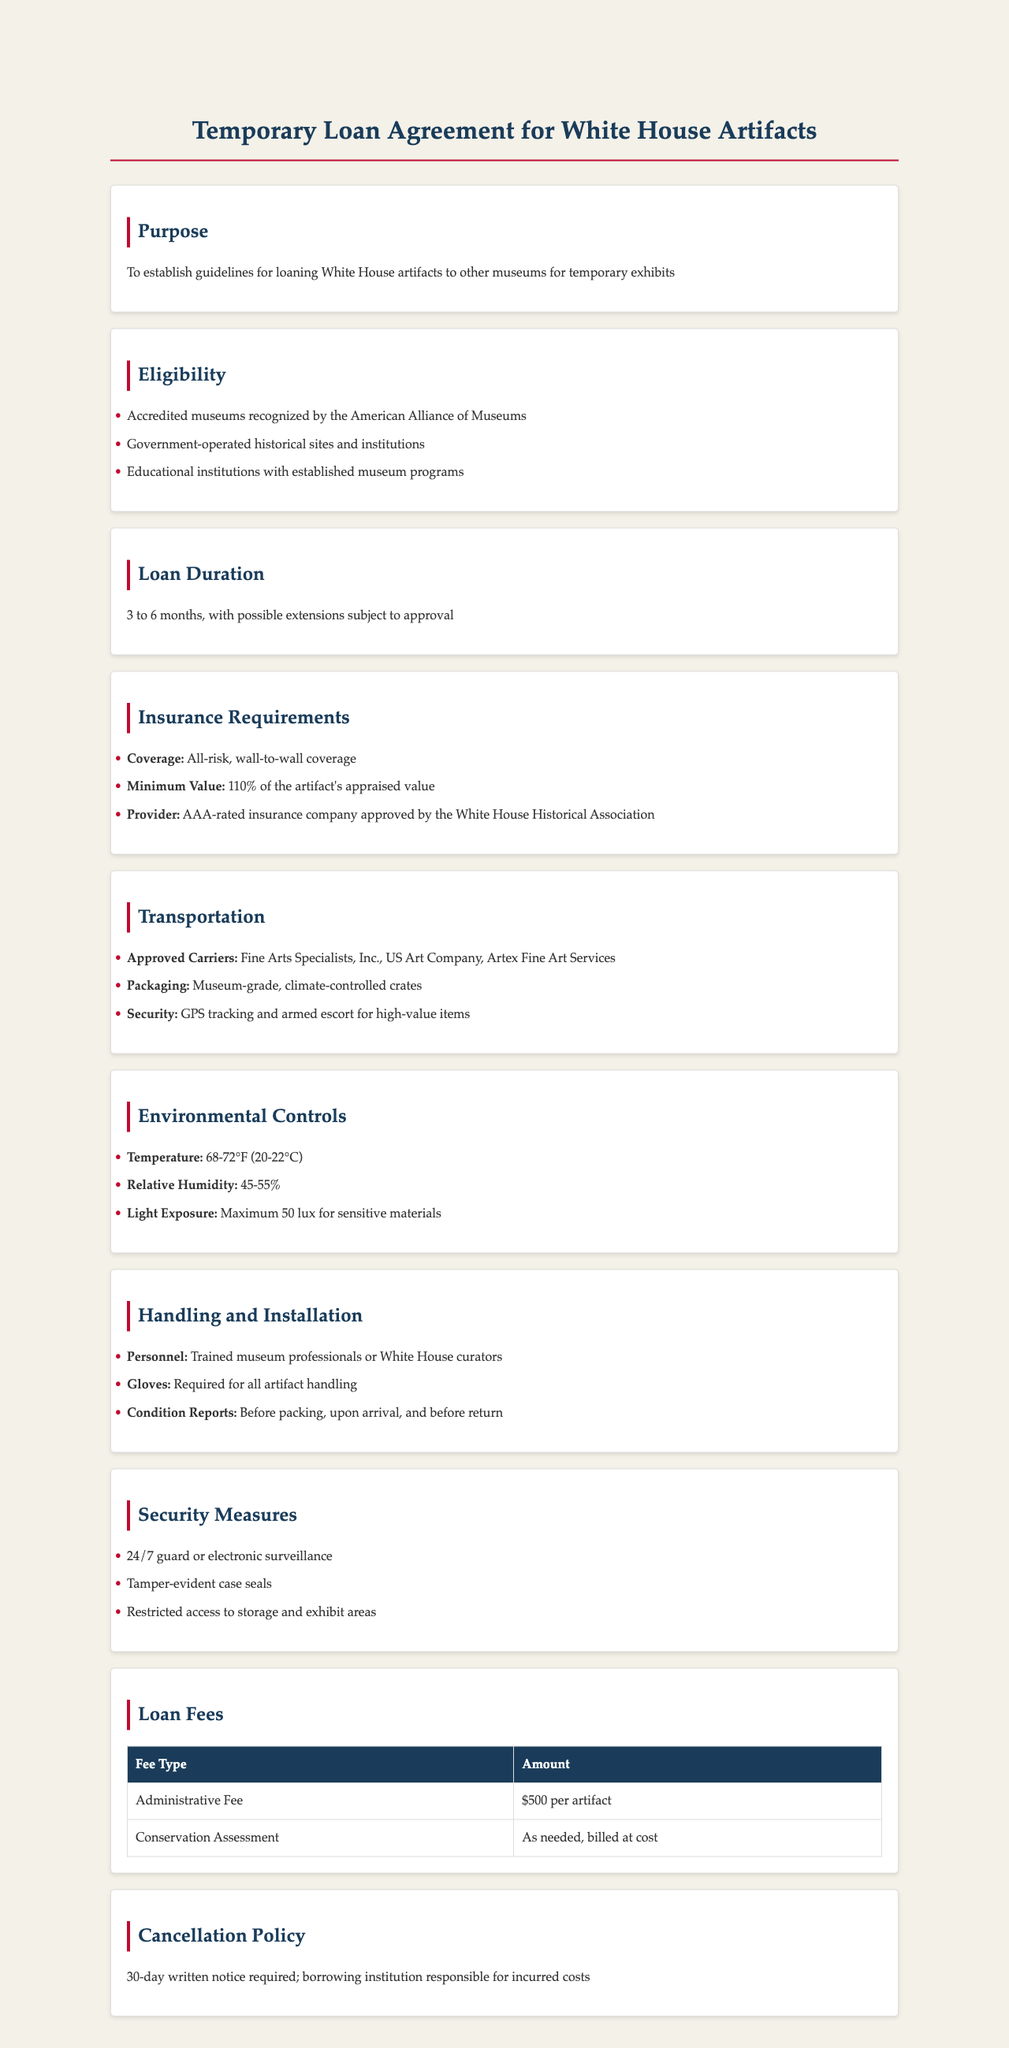What is the duration of loans? The document specifies that loan duration is between 3 to 6 months, with extensions possible subject to approval.
Answer: 3 to 6 months What is the minimum insurance coverage required? The document states that insurance must cover 110% of the artifact's appraised value.
Answer: 110% Which organizations are eligible to borrow artifacts? The list of eligible organizations includes accredited museums, government-operated sites, and educational institutions.
Answer: Accredited museums, government-operated historical sites, educational institutions What is the administrative fee per artifact? According to the document, the administrative fee for a loan is $500 per artifact.
Answer: $500 What security measure is required for high-value items? The document indicates that GPS tracking and armed escort are security measures for high-value items during transportation.
Answer: GPS tracking and armed escort Which companies are approved carriers for transportation? Approved carriers mentioned in the document include Fine Arts Specialists, Inc., US Art Company, and Artex Fine Art Services.
Answer: Fine Arts Specialists, Inc., US Art Company, Artex Fine Art Services What is required for handling artifacts? The handling of artifacts requires trained museum professionals or White House curators as stated in the policy.
Answer: Trained museum professionals or White House curators What is required for cancellation of a loan? The cancellation policy mandates a 30-day written notice for cancellation of a loan.
Answer: 30-day written notice 